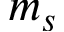Convert formula to latex. <formula><loc_0><loc_0><loc_500><loc_500>m _ { s }</formula> 